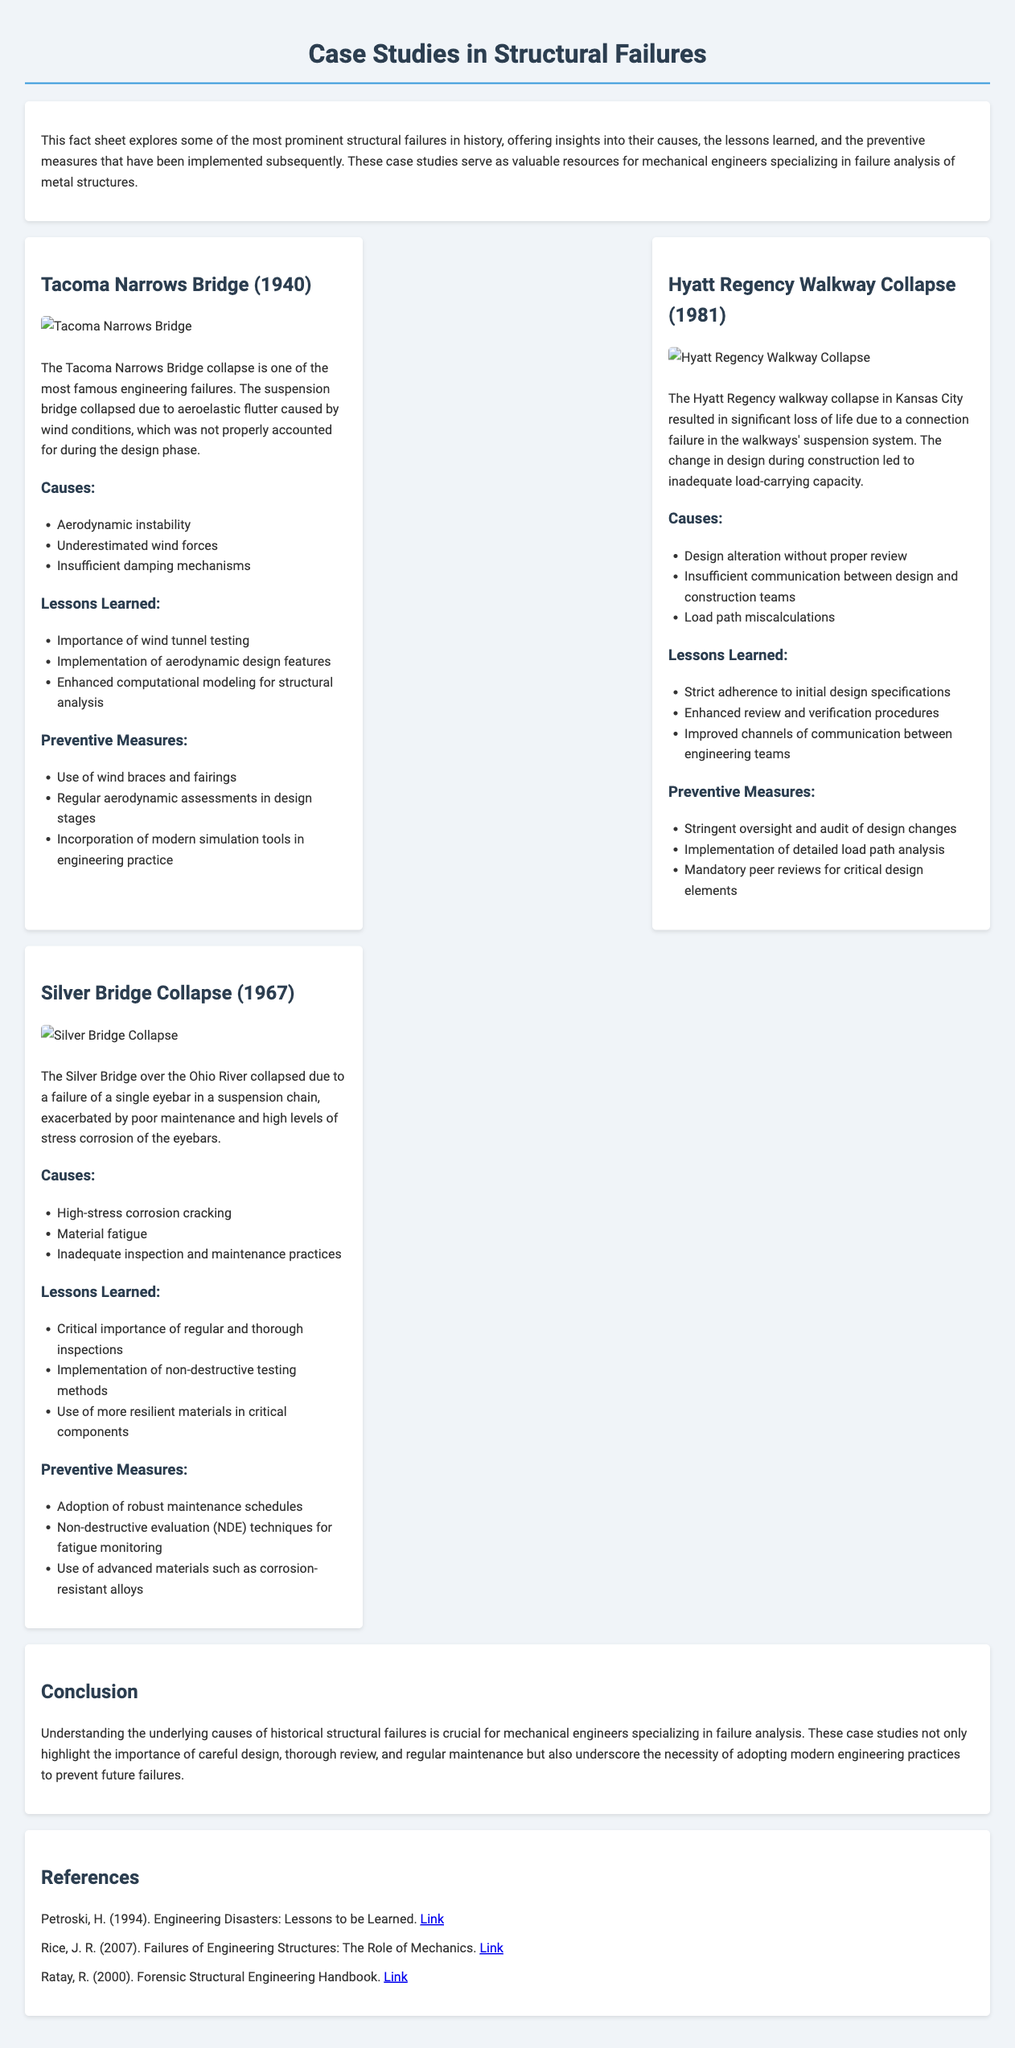What is the title of the fact sheet? The title is the heading at the top of the document, which outlines the main topic of the content.
Answer: Case Studies in Structural Failures What year did the Tacoma Narrows Bridge collapse? The year is mentioned in the first case study section, indicating the date of the event.
Answer: 1940 What major issue caused the Hyatt Regency walkway collapse? This is outlined in the causes section of the case study and identifies a specific failure related to the design process.
Answer: Connection failure What material failure was responsible for the Silver Bridge collapse? This refers to the identified cause in the Silver Bridge case study, as outlined under causes.
Answer: Eyebar failure What preventive measure is recommended for the Tacoma Narrows Bridge? This is one of the suggested actions under the preventive measures section for the Tacoma Narrows Bridge case study.
Answer: Use of wind braces What lesson was learned from the Hyatt Regency Walkway Collapse regarding design changes? This is specified in the lessons learned section, referring to the need for thorough review of design modifications.
Answer: Strict adherence to initial design specifications What key inspection method is suggested in the lessons learned from the Silver Bridge failure? This method is identified under the lessons learned section, emphasizing evaluation techniques for structural integrity.
Answer: Non-destructive testing What is the primary focus of the fact sheet? The primary focus is reflected in the introduction, summarizing the document's overall intent and content theme.
Answer: Structural failures analysis 